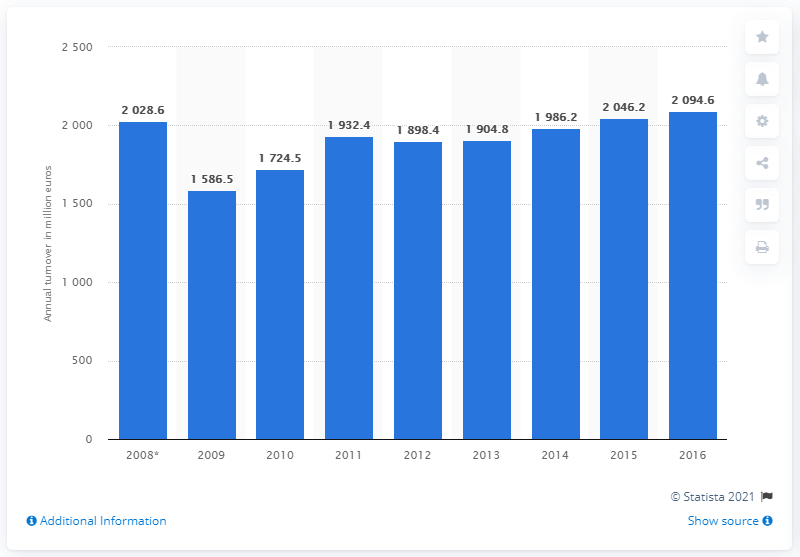Point out several critical features in this image. According to data from 2016, the turnover of the textile manufacturing industry was 2094.6 billion. 